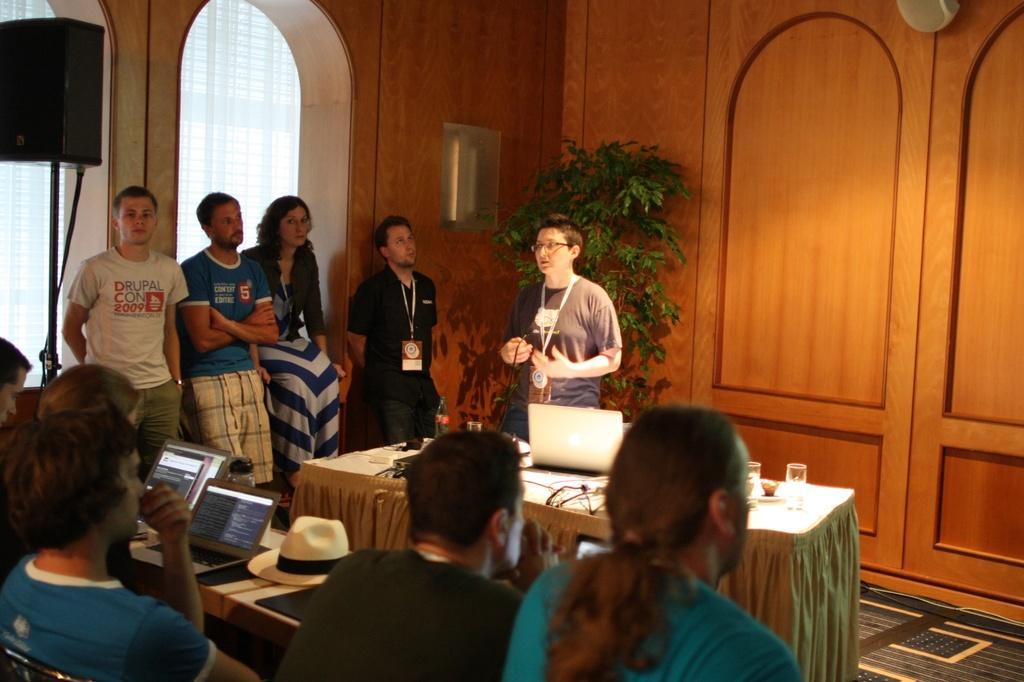In one or two sentences, can you explain what this image depicts? In this picture we can see some persons are sitting on the chairs. These are the tables. On the table there are laptops, hat, and glasses. Here we can see some persons are standing on the floor. This is plant and there is a wall. 